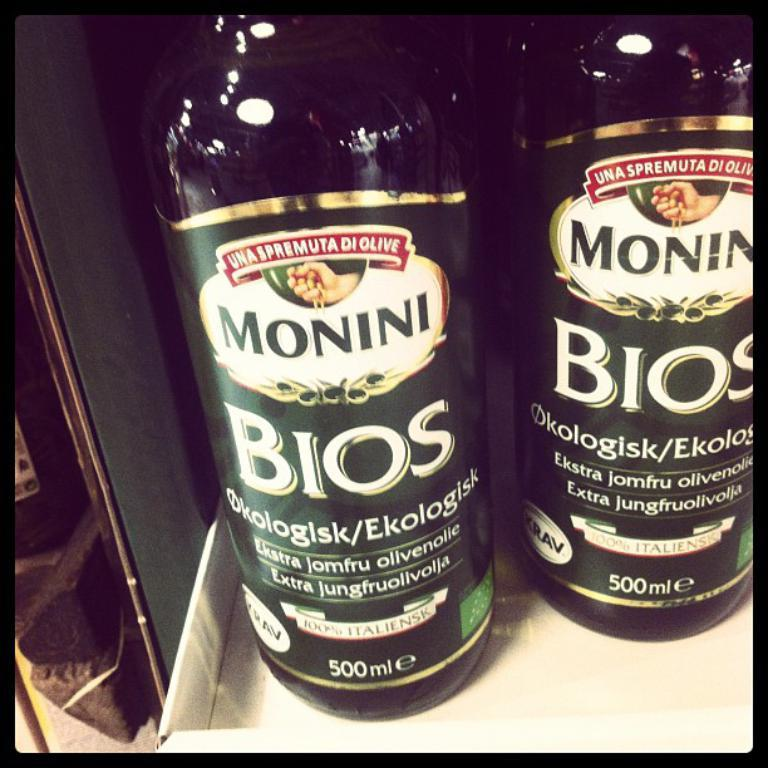<image>
Summarize the visual content of the image. Two bottles have the brand name Bios on them. 